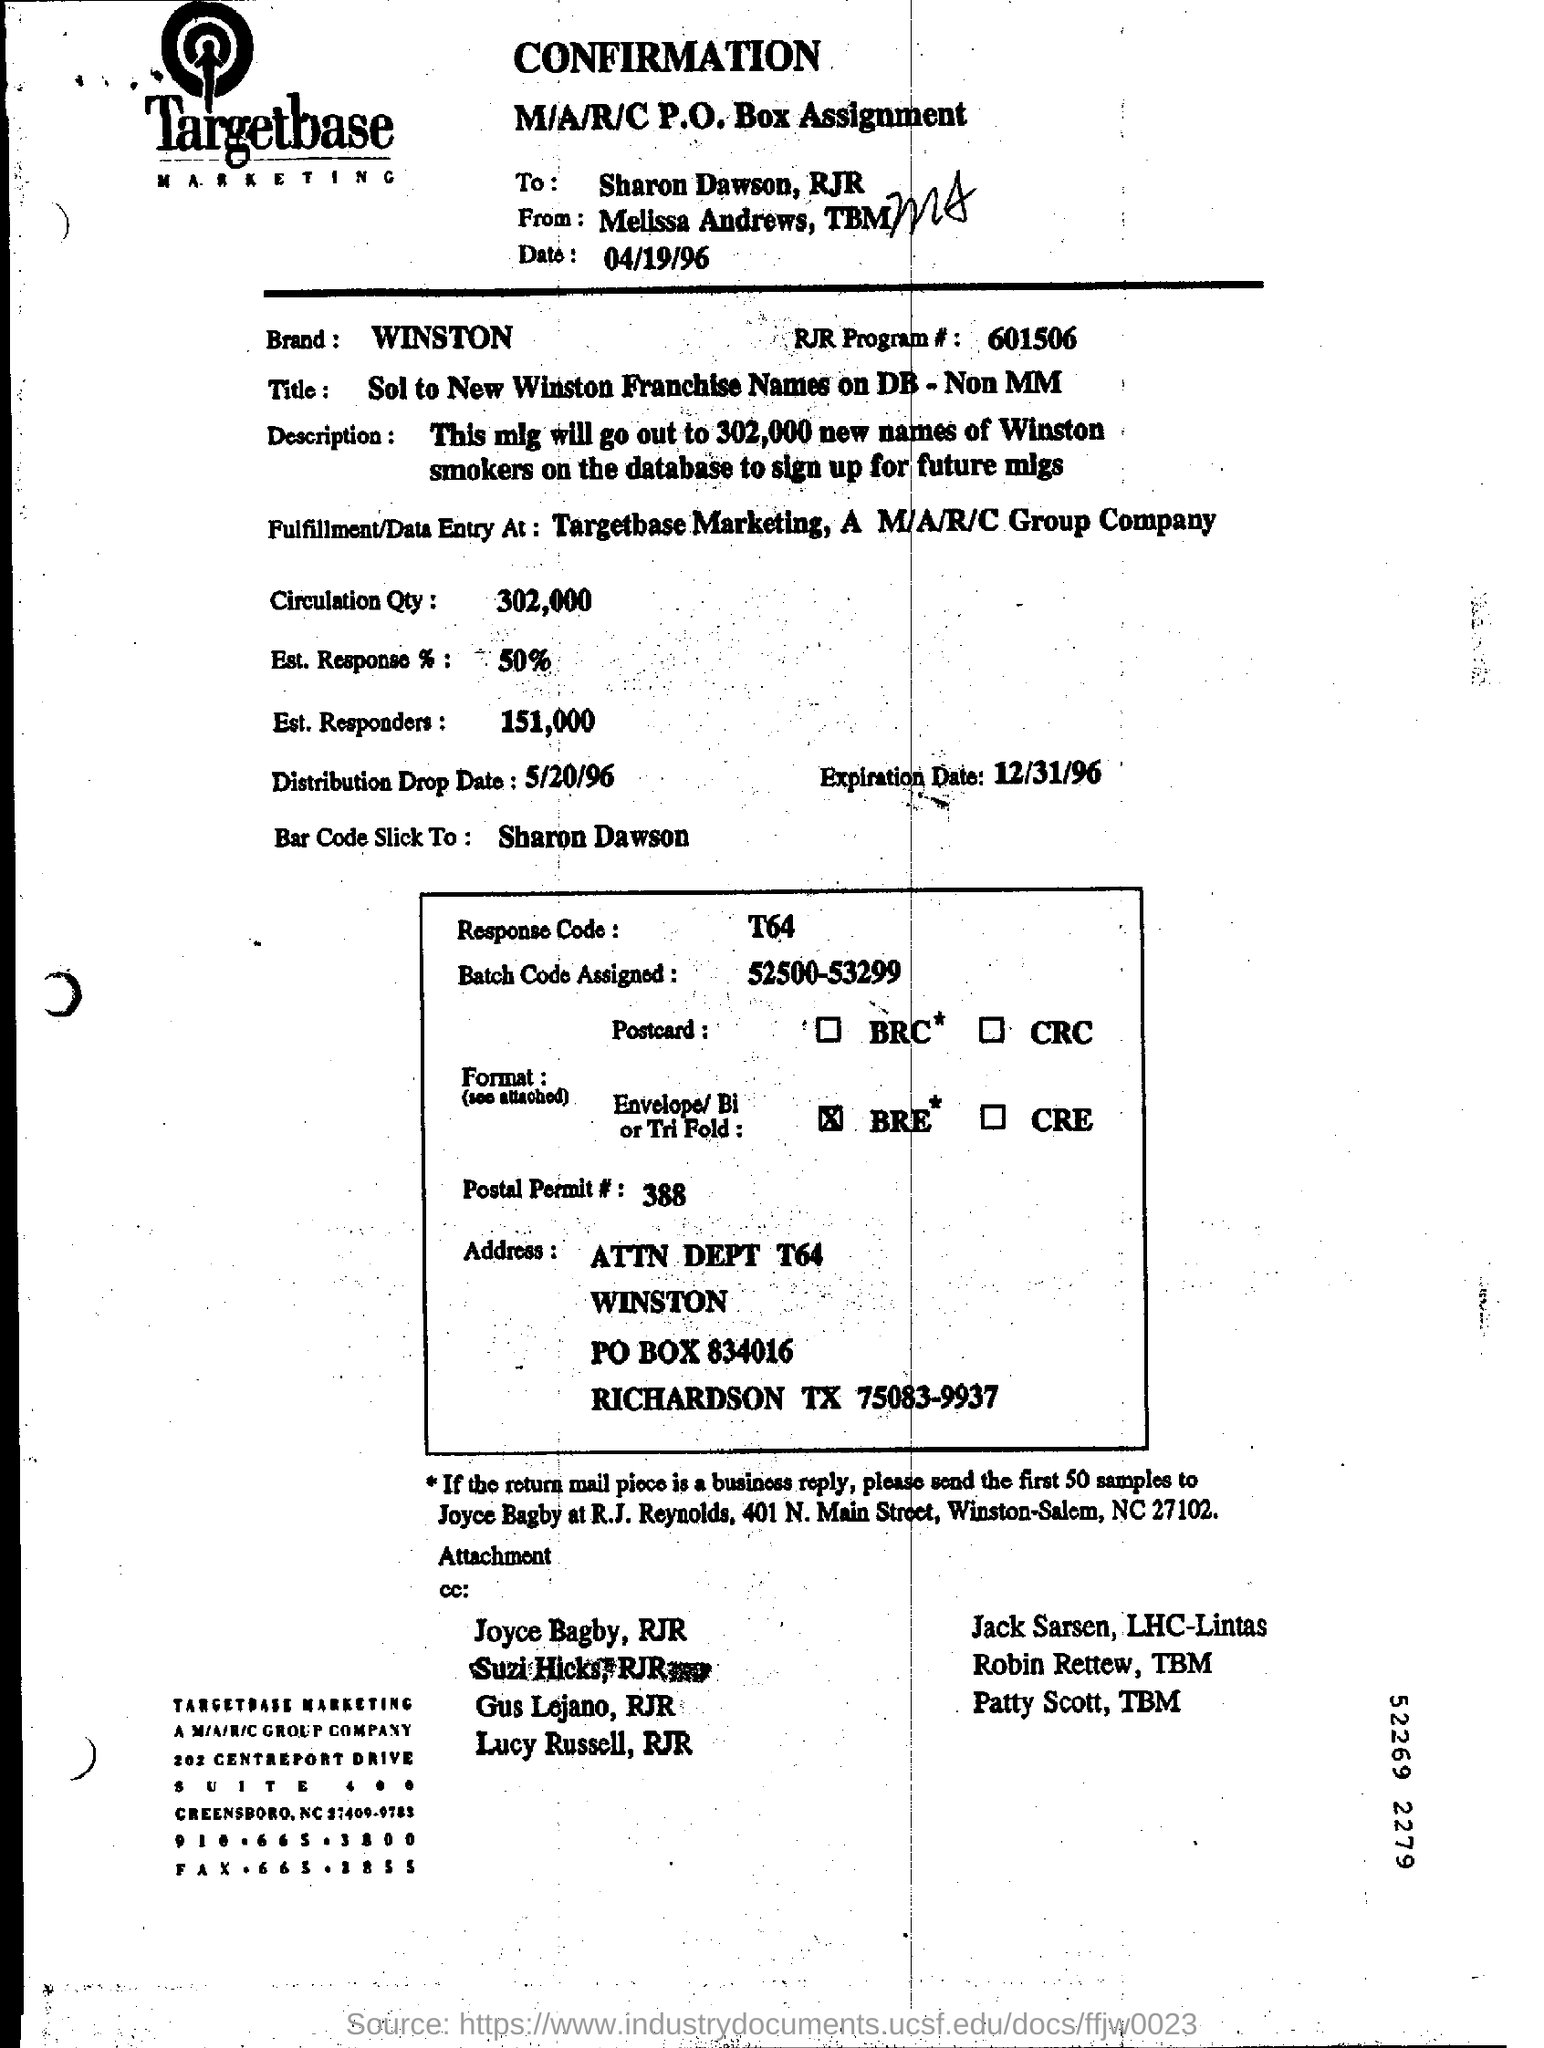What is the purpose of the Batch Code on this document? The Batch Code, in this case 'T64', likely functions as an identifier for tracking the production, distribution, or response to a specific batch of materials related to the marketing campaign. Is it common to use such codes in marketing? Yes, it's common practice in marketing and logistics to use batch codes or similar identifiers to efficiently track and manage different segments of a campaign for reporting and analysis purposes. 